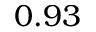Convert formula to latex. <formula><loc_0><loc_0><loc_500><loc_500>0 . 9 3</formula> 